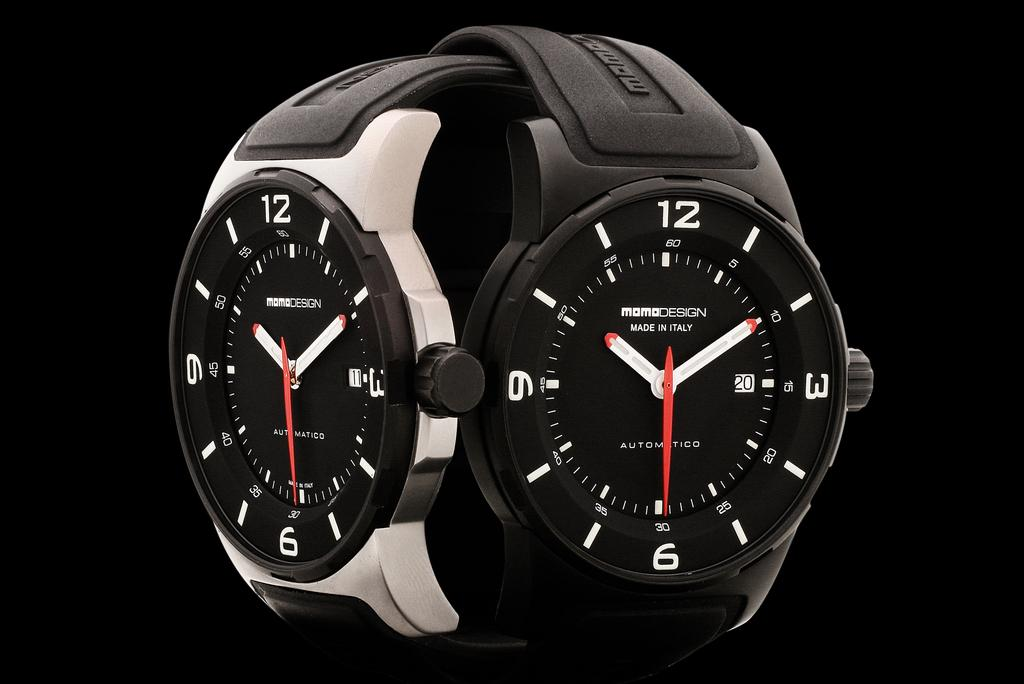<image>
Provide a brief description of the given image. Watch that has a silver color and says MomoDesign Made in Italy with the time 10:10. 